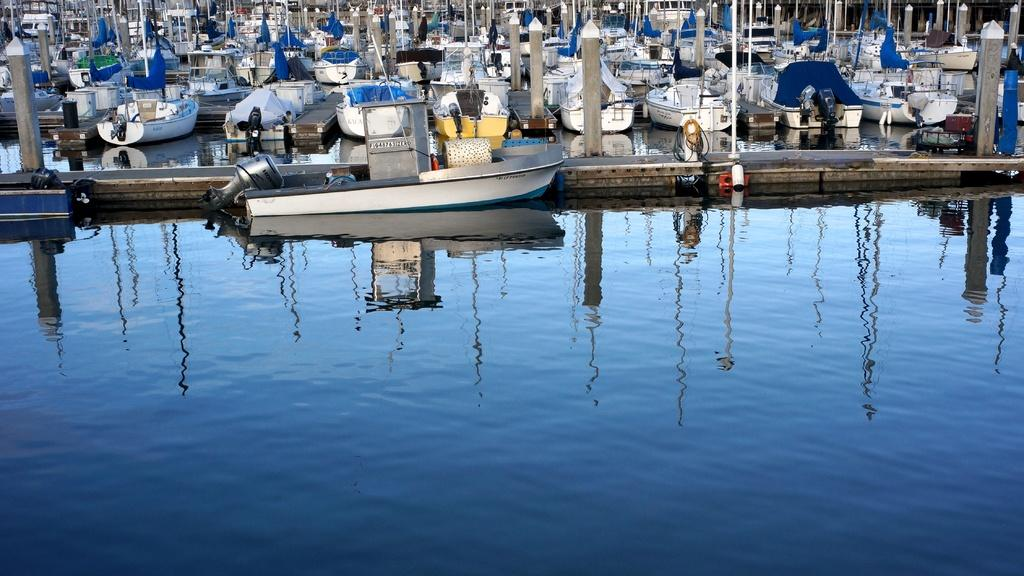What can be seen in the water in the image? There are reflections of objects in the water. What type of vehicles are visible in the image? There are boats visible in the image. What structures are present in the image? There are poles present in the image. What else can be seen on the boats in the image? There are other objects on the boats. What caption is written on the boats in the image? There is no caption visible on the boats in the image. Can you tell me how many times the objects on the boats are kicked in the image? There is no indication of anyone kicking objects on the boats in the image. 